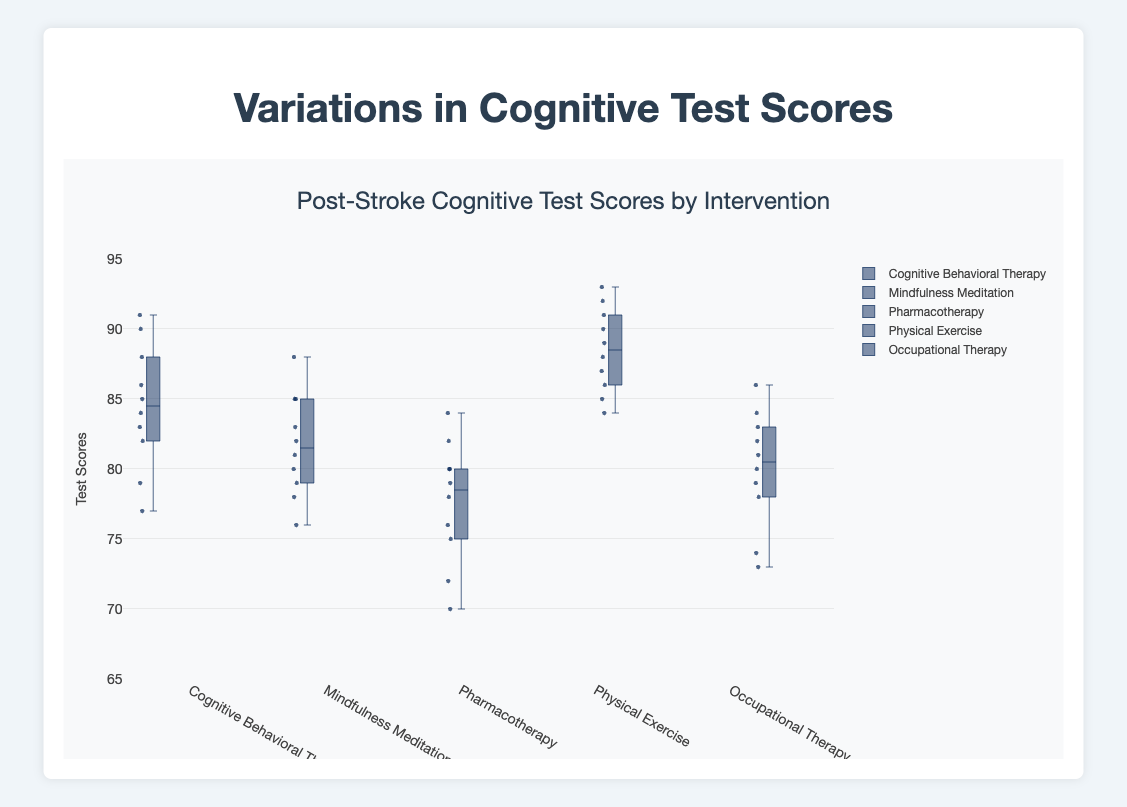What is the title of the figure? The title is shown at the top-center of the figure. It reads "Post-Stroke Cognitive Test Scores by Intervention."
Answer: Post-Stroke Cognitive Test Scores by Intervention What range of scores does the y-axis cover? The y-axis covers a range from the minimum value of 65 to the maximum value of 95.
Answer: 65 to 95 Which intervention has the highest median cognitive test score? The median is indicated by the line inside each box. The intervention "Physical Exercise" has the highest median, as the line is at a higher position compared to the others.
Answer: Physical Exercise How many interventions are compared in the plot? Each box represents a different intervention; there are five distinct boxes, so five interventions are compared.
Answer: Five What is the median test score for Pharmacotherapy? The median value for Pharmacotherapy is indicated by the line inside the box for Pharmacotherapy, which appears at around 78.
Answer: 78 Which intervention shows the largest interquartile range (IQR)? The IQR is the range within the box, between the lower quartile (Q1) and upper quartile (Q3). The "Physical Exercise" intervention has the largest interquartile range as its box is tallest compared to others.
Answer: Physical Exercise Are there any noticeable outliers in the data? If so, which intervention do they belong to? Outliers are generally indicated by points outside the whiskers of the box plot. Here, there are no obvious outliers visible, as no points lie beyond the whiskers in the plot.
Answer: No What is the approximate range of test scores for Cognitive Behavioral Therapy? The range, indicated by the whiskers, extends from 77 (min) to 91 (max).
Answer: 77 to 91 Between Mindfulness Meditation and Occupational Therapy, which intervention has a higher upper quartile (Q3)? The upper quartile (Q3) is the top edge of the box. Mindfulness Meditation has a higher Q3 than Occupational Therapy.
Answer: Mindfulness Meditation 